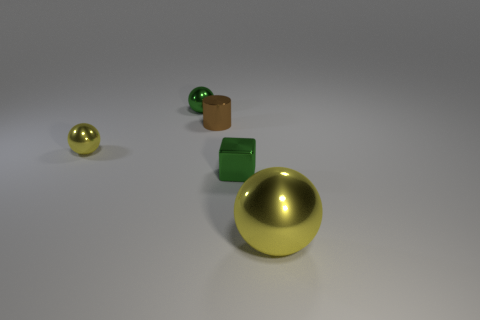There is a yellow shiny thing in front of the small yellow metal thing on the left side of the big shiny thing; what shape is it?
Keep it short and to the point. Sphere. Is the number of tiny metallic cylinders in front of the brown thing less than the number of gray metal things?
Offer a very short reply. No. The tiny brown metal thing has what shape?
Provide a short and direct response. Cylinder. There is a object that is to the left of the green ball; what is its size?
Keep it short and to the point. Small. The cube that is the same size as the brown shiny cylinder is what color?
Offer a very short reply. Green. Is there a tiny object that has the same color as the cube?
Keep it short and to the point. Yes. Are there fewer big yellow metal balls behind the tiny yellow shiny ball than yellow things that are behind the big metallic object?
Offer a very short reply. Yes. There is a ball that is both behind the block and to the right of the tiny yellow ball; what material is it made of?
Give a very brief answer. Metal. There is a big yellow thing; is its shape the same as the tiny green thing that is in front of the small green metal sphere?
Ensure brevity in your answer.  No. What number of other things are the same size as the brown cylinder?
Ensure brevity in your answer.  3. 